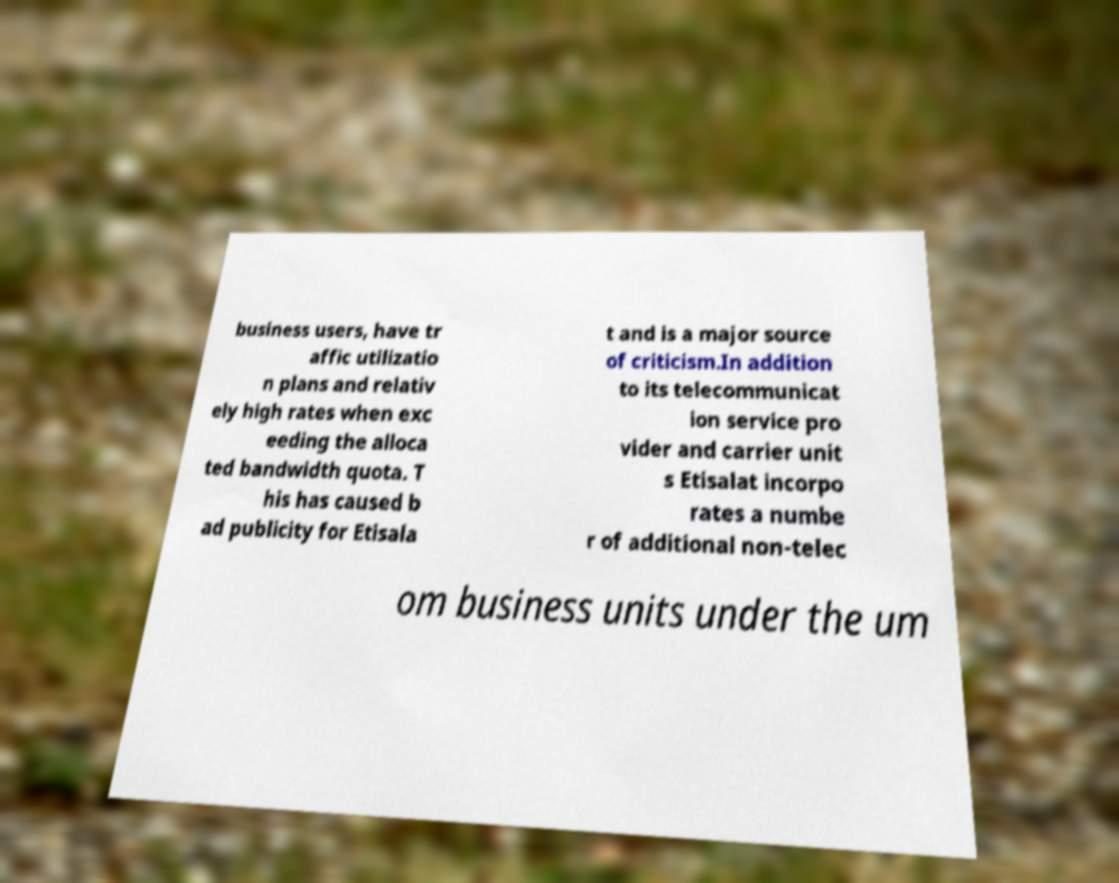Could you extract and type out the text from this image? business users, have tr affic utilizatio n plans and relativ ely high rates when exc eeding the alloca ted bandwidth quota. T his has caused b ad publicity for Etisala t and is a major source of criticism.In addition to its telecommunicat ion service pro vider and carrier unit s Etisalat incorpo rates a numbe r of additional non-telec om business units under the um 